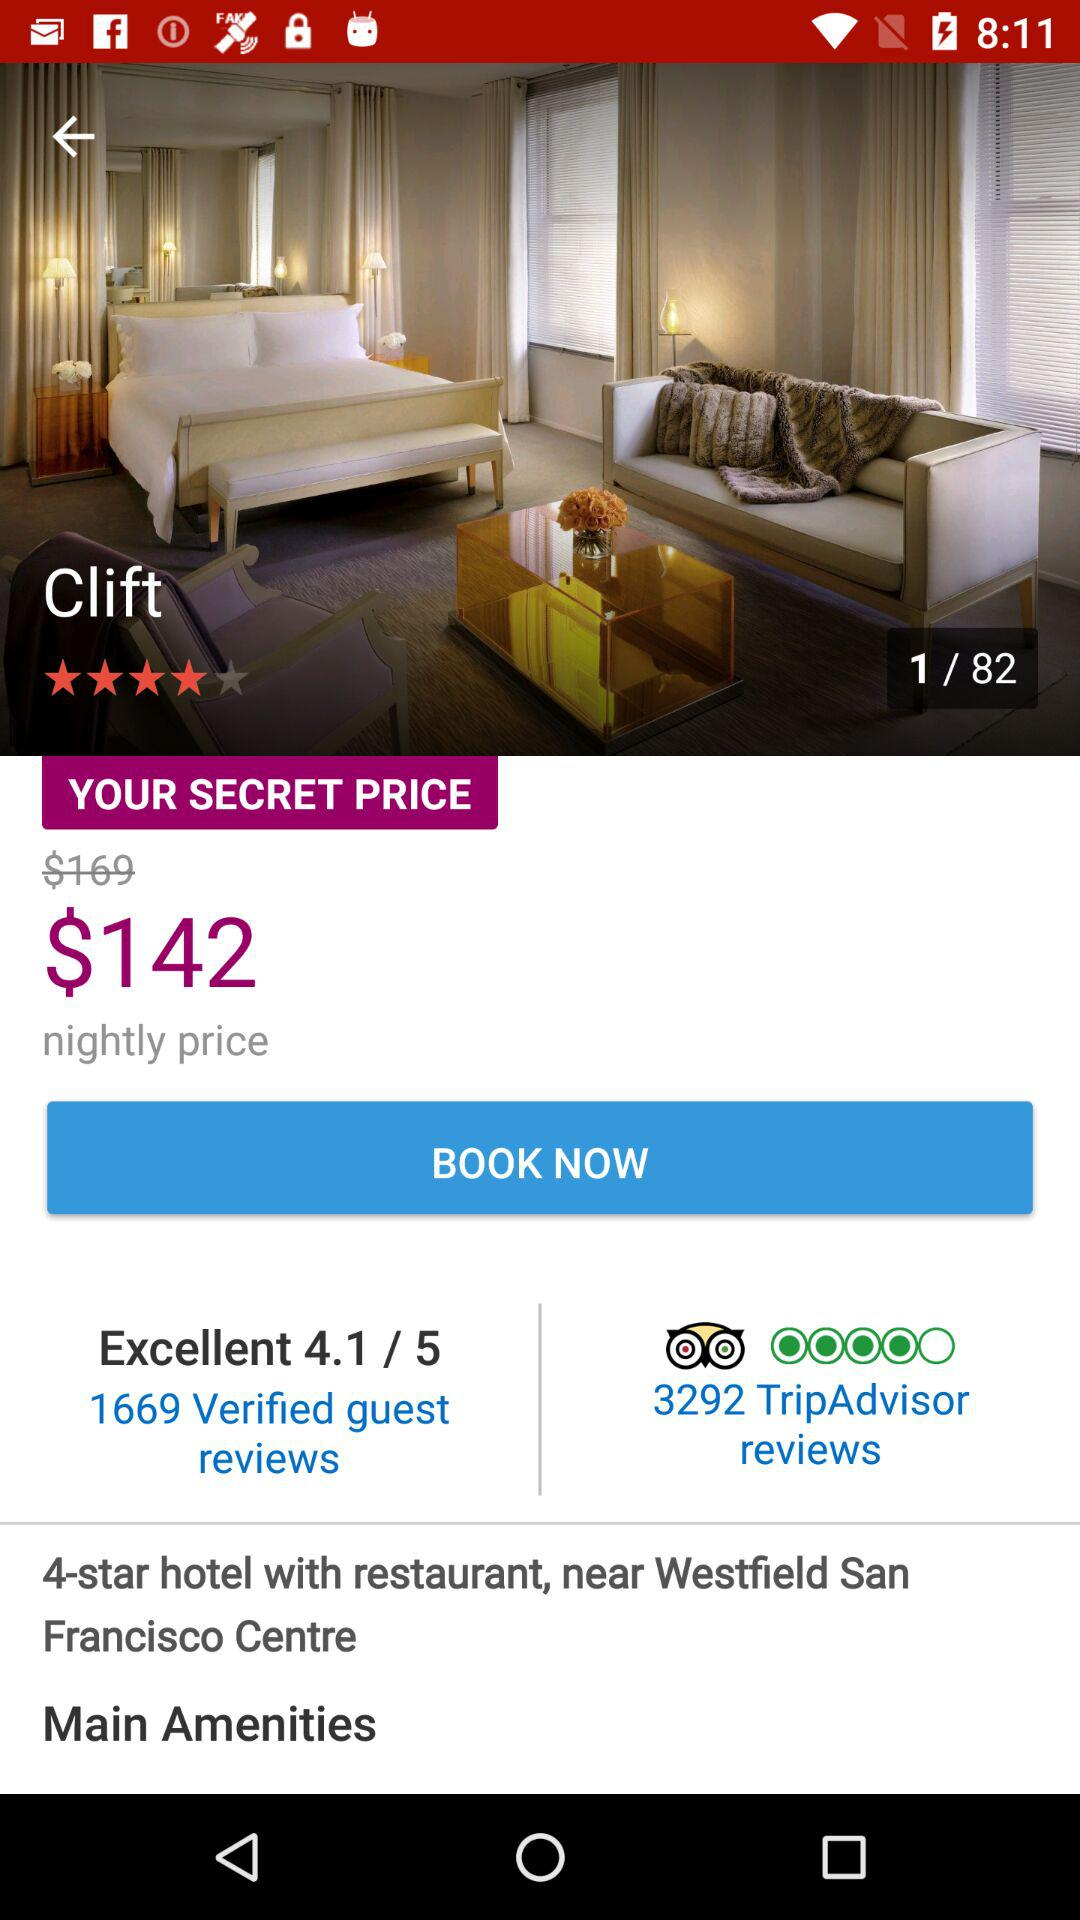How much is the nightly price?
Answer the question using a single word or phrase. $142 